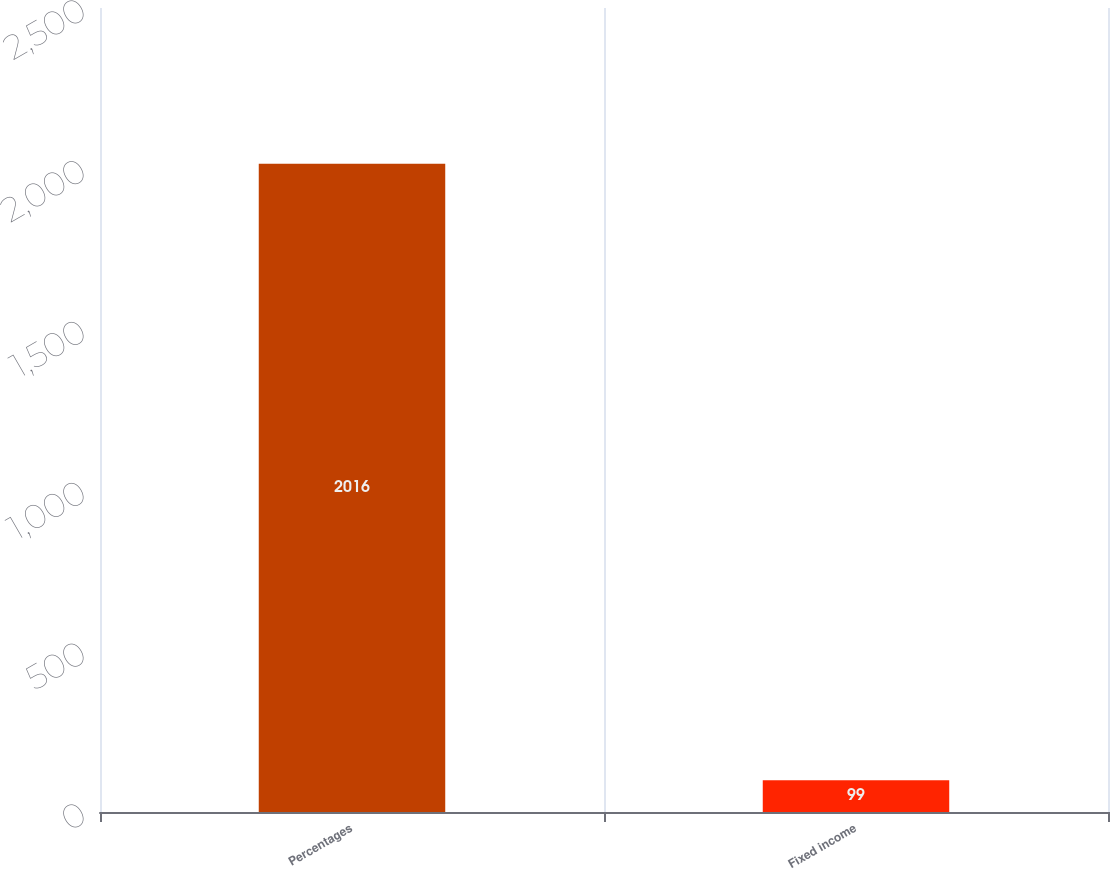<chart> <loc_0><loc_0><loc_500><loc_500><bar_chart><fcel>Percentages<fcel>Fixed income<nl><fcel>2016<fcel>99<nl></chart> 